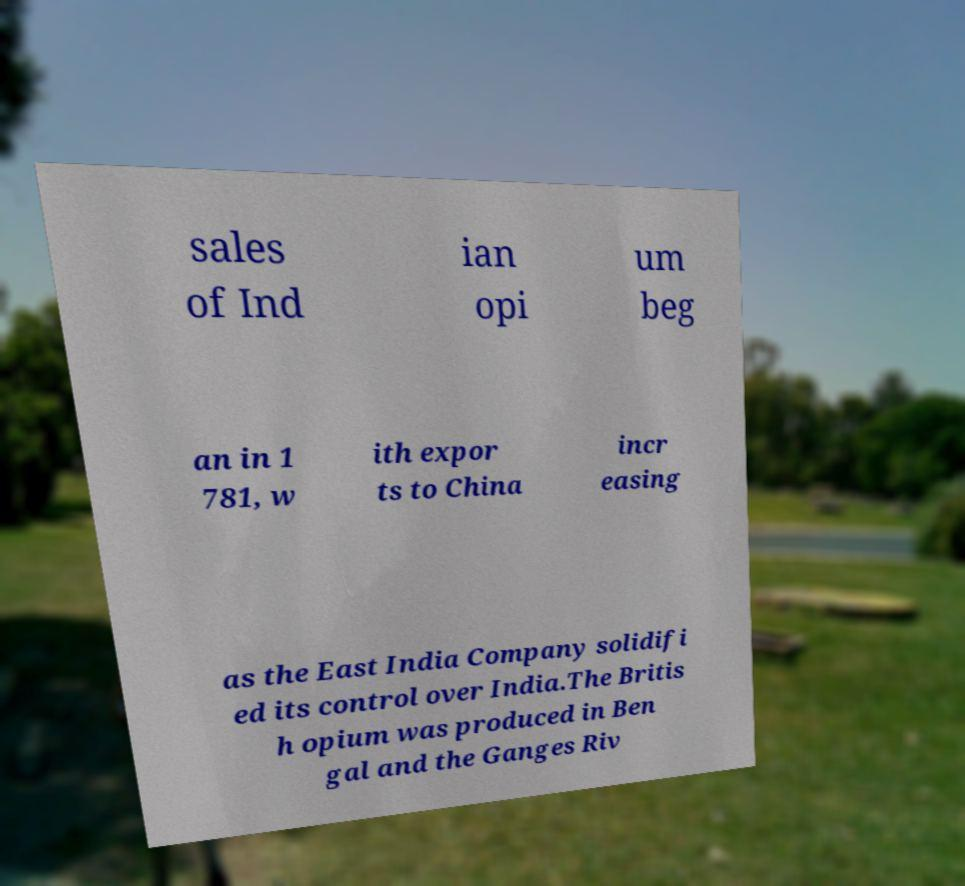Please identify and transcribe the text found in this image. sales of Ind ian opi um beg an in 1 781, w ith expor ts to China incr easing as the East India Company solidifi ed its control over India.The Britis h opium was produced in Ben gal and the Ganges Riv 